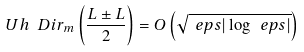Convert formula to latex. <formula><loc_0><loc_0><loc_500><loc_500>U h ^ { \ } D i r _ { m } \left ( \frac { L \pm L } { 2 } \right ) = O \left ( \sqrt { \ e p s | \log \ e p s | } \right )</formula> 